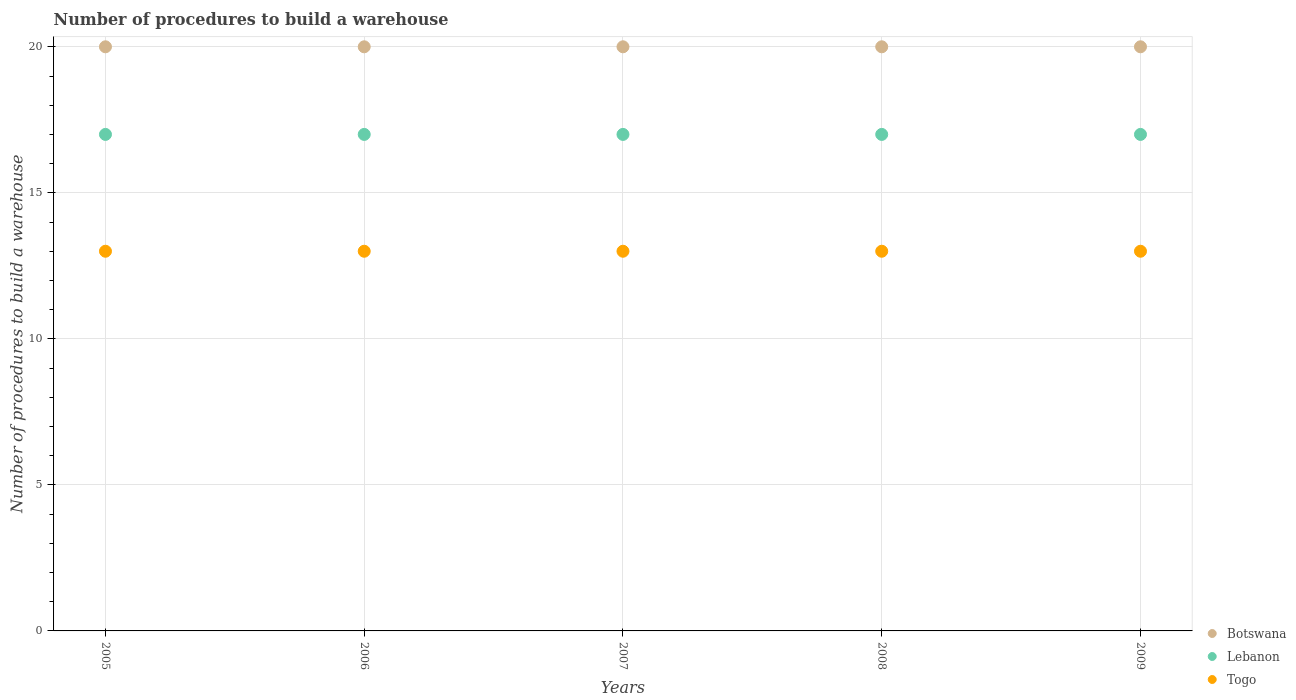How many different coloured dotlines are there?
Keep it short and to the point. 3. What is the number of procedures to build a warehouse in in Lebanon in 2005?
Your answer should be compact. 17. Across all years, what is the maximum number of procedures to build a warehouse in in Botswana?
Provide a succinct answer. 20. Across all years, what is the minimum number of procedures to build a warehouse in in Togo?
Make the answer very short. 13. In which year was the number of procedures to build a warehouse in in Lebanon maximum?
Keep it short and to the point. 2005. In which year was the number of procedures to build a warehouse in in Lebanon minimum?
Ensure brevity in your answer.  2005. What is the total number of procedures to build a warehouse in in Togo in the graph?
Your answer should be compact. 65. What is the difference between the number of procedures to build a warehouse in in Lebanon in 2008 and that in 2009?
Give a very brief answer. 0. What is the difference between the number of procedures to build a warehouse in in Lebanon in 2006 and the number of procedures to build a warehouse in in Togo in 2008?
Provide a short and direct response. 4. In the year 2009, what is the difference between the number of procedures to build a warehouse in in Botswana and number of procedures to build a warehouse in in Lebanon?
Offer a terse response. 3. In how many years, is the number of procedures to build a warehouse in in Togo greater than 13?
Provide a short and direct response. 0. Is the number of procedures to build a warehouse in in Lebanon in 2006 less than that in 2007?
Offer a very short reply. No. What is the difference between the highest and the second highest number of procedures to build a warehouse in in Botswana?
Provide a succinct answer. 0. In how many years, is the number of procedures to build a warehouse in in Lebanon greater than the average number of procedures to build a warehouse in in Lebanon taken over all years?
Your answer should be very brief. 0. Is it the case that in every year, the sum of the number of procedures to build a warehouse in in Togo and number of procedures to build a warehouse in in Lebanon  is greater than the number of procedures to build a warehouse in in Botswana?
Provide a succinct answer. Yes. Does the number of procedures to build a warehouse in in Lebanon monotonically increase over the years?
Your answer should be compact. No. Is the number of procedures to build a warehouse in in Botswana strictly greater than the number of procedures to build a warehouse in in Lebanon over the years?
Ensure brevity in your answer.  Yes. How many years are there in the graph?
Your answer should be compact. 5. What is the difference between two consecutive major ticks on the Y-axis?
Your answer should be very brief. 5. Does the graph contain any zero values?
Keep it short and to the point. No. How many legend labels are there?
Make the answer very short. 3. What is the title of the graph?
Ensure brevity in your answer.  Number of procedures to build a warehouse. Does "Costa Rica" appear as one of the legend labels in the graph?
Your answer should be very brief. No. What is the label or title of the X-axis?
Keep it short and to the point. Years. What is the label or title of the Y-axis?
Ensure brevity in your answer.  Number of procedures to build a warehouse. What is the Number of procedures to build a warehouse in Lebanon in 2007?
Ensure brevity in your answer.  17. What is the Number of procedures to build a warehouse of Togo in 2007?
Make the answer very short. 13. What is the Number of procedures to build a warehouse in Togo in 2008?
Offer a very short reply. 13. What is the Number of procedures to build a warehouse of Botswana in 2009?
Your answer should be very brief. 20. What is the Number of procedures to build a warehouse in Togo in 2009?
Keep it short and to the point. 13. Across all years, what is the maximum Number of procedures to build a warehouse of Lebanon?
Give a very brief answer. 17. Across all years, what is the maximum Number of procedures to build a warehouse in Togo?
Keep it short and to the point. 13. Across all years, what is the minimum Number of procedures to build a warehouse in Lebanon?
Ensure brevity in your answer.  17. What is the total Number of procedures to build a warehouse in Togo in the graph?
Your answer should be compact. 65. What is the difference between the Number of procedures to build a warehouse in Lebanon in 2005 and that in 2006?
Provide a short and direct response. 0. What is the difference between the Number of procedures to build a warehouse of Togo in 2005 and that in 2006?
Your answer should be very brief. 0. What is the difference between the Number of procedures to build a warehouse of Lebanon in 2005 and that in 2007?
Give a very brief answer. 0. What is the difference between the Number of procedures to build a warehouse of Lebanon in 2005 and that in 2008?
Provide a short and direct response. 0. What is the difference between the Number of procedures to build a warehouse in Togo in 2005 and that in 2008?
Your answer should be very brief. 0. What is the difference between the Number of procedures to build a warehouse of Botswana in 2005 and that in 2009?
Provide a short and direct response. 0. What is the difference between the Number of procedures to build a warehouse of Togo in 2005 and that in 2009?
Offer a very short reply. 0. What is the difference between the Number of procedures to build a warehouse in Botswana in 2006 and that in 2007?
Ensure brevity in your answer.  0. What is the difference between the Number of procedures to build a warehouse in Lebanon in 2006 and that in 2007?
Make the answer very short. 0. What is the difference between the Number of procedures to build a warehouse in Botswana in 2006 and that in 2008?
Keep it short and to the point. 0. What is the difference between the Number of procedures to build a warehouse of Togo in 2006 and that in 2008?
Give a very brief answer. 0. What is the difference between the Number of procedures to build a warehouse of Lebanon in 2006 and that in 2009?
Your answer should be compact. 0. What is the difference between the Number of procedures to build a warehouse of Togo in 2006 and that in 2009?
Give a very brief answer. 0. What is the difference between the Number of procedures to build a warehouse of Botswana in 2007 and that in 2009?
Ensure brevity in your answer.  0. What is the difference between the Number of procedures to build a warehouse in Togo in 2007 and that in 2009?
Your answer should be compact. 0. What is the difference between the Number of procedures to build a warehouse of Botswana in 2008 and that in 2009?
Ensure brevity in your answer.  0. What is the difference between the Number of procedures to build a warehouse in Lebanon in 2008 and that in 2009?
Ensure brevity in your answer.  0. What is the difference between the Number of procedures to build a warehouse in Togo in 2008 and that in 2009?
Ensure brevity in your answer.  0. What is the difference between the Number of procedures to build a warehouse of Botswana in 2005 and the Number of procedures to build a warehouse of Lebanon in 2006?
Provide a short and direct response. 3. What is the difference between the Number of procedures to build a warehouse of Botswana in 2005 and the Number of procedures to build a warehouse of Togo in 2006?
Give a very brief answer. 7. What is the difference between the Number of procedures to build a warehouse of Lebanon in 2005 and the Number of procedures to build a warehouse of Togo in 2006?
Give a very brief answer. 4. What is the difference between the Number of procedures to build a warehouse of Botswana in 2005 and the Number of procedures to build a warehouse of Lebanon in 2008?
Keep it short and to the point. 3. What is the difference between the Number of procedures to build a warehouse of Botswana in 2005 and the Number of procedures to build a warehouse of Togo in 2008?
Offer a terse response. 7. What is the difference between the Number of procedures to build a warehouse in Lebanon in 2005 and the Number of procedures to build a warehouse in Togo in 2008?
Give a very brief answer. 4. What is the difference between the Number of procedures to build a warehouse of Botswana in 2005 and the Number of procedures to build a warehouse of Lebanon in 2009?
Your answer should be compact. 3. What is the difference between the Number of procedures to build a warehouse of Lebanon in 2005 and the Number of procedures to build a warehouse of Togo in 2009?
Keep it short and to the point. 4. What is the difference between the Number of procedures to build a warehouse of Botswana in 2006 and the Number of procedures to build a warehouse of Togo in 2007?
Give a very brief answer. 7. What is the difference between the Number of procedures to build a warehouse in Lebanon in 2006 and the Number of procedures to build a warehouse in Togo in 2007?
Keep it short and to the point. 4. What is the difference between the Number of procedures to build a warehouse in Botswana in 2006 and the Number of procedures to build a warehouse in Lebanon in 2008?
Offer a very short reply. 3. What is the difference between the Number of procedures to build a warehouse in Lebanon in 2006 and the Number of procedures to build a warehouse in Togo in 2008?
Provide a short and direct response. 4. What is the difference between the Number of procedures to build a warehouse in Lebanon in 2006 and the Number of procedures to build a warehouse in Togo in 2009?
Ensure brevity in your answer.  4. What is the difference between the Number of procedures to build a warehouse of Botswana in 2007 and the Number of procedures to build a warehouse of Lebanon in 2008?
Your answer should be compact. 3. What is the difference between the Number of procedures to build a warehouse in Botswana in 2007 and the Number of procedures to build a warehouse in Togo in 2009?
Your response must be concise. 7. What is the difference between the Number of procedures to build a warehouse of Lebanon in 2007 and the Number of procedures to build a warehouse of Togo in 2009?
Provide a short and direct response. 4. What is the difference between the Number of procedures to build a warehouse in Botswana in 2008 and the Number of procedures to build a warehouse in Togo in 2009?
Provide a short and direct response. 7. What is the difference between the Number of procedures to build a warehouse in Lebanon in 2008 and the Number of procedures to build a warehouse in Togo in 2009?
Offer a very short reply. 4. What is the average Number of procedures to build a warehouse of Botswana per year?
Your answer should be very brief. 20. In the year 2005, what is the difference between the Number of procedures to build a warehouse in Botswana and Number of procedures to build a warehouse in Togo?
Provide a succinct answer. 7. In the year 2006, what is the difference between the Number of procedures to build a warehouse in Botswana and Number of procedures to build a warehouse in Togo?
Provide a succinct answer. 7. In the year 2007, what is the difference between the Number of procedures to build a warehouse of Botswana and Number of procedures to build a warehouse of Lebanon?
Give a very brief answer. 3. In the year 2008, what is the difference between the Number of procedures to build a warehouse of Botswana and Number of procedures to build a warehouse of Lebanon?
Provide a succinct answer. 3. In the year 2009, what is the difference between the Number of procedures to build a warehouse in Botswana and Number of procedures to build a warehouse in Lebanon?
Give a very brief answer. 3. In the year 2009, what is the difference between the Number of procedures to build a warehouse in Botswana and Number of procedures to build a warehouse in Togo?
Your answer should be compact. 7. What is the ratio of the Number of procedures to build a warehouse in Lebanon in 2005 to that in 2006?
Make the answer very short. 1. What is the ratio of the Number of procedures to build a warehouse in Togo in 2005 to that in 2006?
Your answer should be very brief. 1. What is the ratio of the Number of procedures to build a warehouse in Botswana in 2005 to that in 2007?
Ensure brevity in your answer.  1. What is the ratio of the Number of procedures to build a warehouse of Togo in 2005 to that in 2007?
Give a very brief answer. 1. What is the ratio of the Number of procedures to build a warehouse of Lebanon in 2005 to that in 2008?
Offer a very short reply. 1. What is the ratio of the Number of procedures to build a warehouse in Togo in 2005 to that in 2008?
Your response must be concise. 1. What is the ratio of the Number of procedures to build a warehouse of Lebanon in 2005 to that in 2009?
Your answer should be very brief. 1. What is the ratio of the Number of procedures to build a warehouse in Togo in 2005 to that in 2009?
Give a very brief answer. 1. What is the ratio of the Number of procedures to build a warehouse in Lebanon in 2006 to that in 2007?
Provide a short and direct response. 1. What is the ratio of the Number of procedures to build a warehouse of Botswana in 2006 to that in 2008?
Make the answer very short. 1. What is the ratio of the Number of procedures to build a warehouse of Lebanon in 2006 to that in 2008?
Ensure brevity in your answer.  1. What is the ratio of the Number of procedures to build a warehouse of Togo in 2006 to that in 2008?
Provide a succinct answer. 1. What is the ratio of the Number of procedures to build a warehouse in Botswana in 2006 to that in 2009?
Keep it short and to the point. 1. What is the ratio of the Number of procedures to build a warehouse in Lebanon in 2006 to that in 2009?
Offer a very short reply. 1. What is the ratio of the Number of procedures to build a warehouse in Togo in 2006 to that in 2009?
Give a very brief answer. 1. What is the ratio of the Number of procedures to build a warehouse in Lebanon in 2007 to that in 2009?
Offer a terse response. 1. What is the ratio of the Number of procedures to build a warehouse in Lebanon in 2008 to that in 2009?
Offer a very short reply. 1. What is the difference between the highest and the second highest Number of procedures to build a warehouse in Lebanon?
Make the answer very short. 0. What is the difference between the highest and the second highest Number of procedures to build a warehouse of Togo?
Provide a succinct answer. 0. 